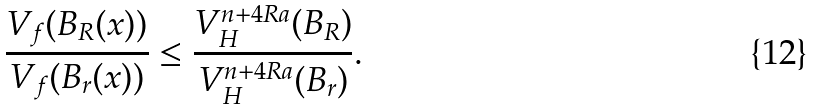<formula> <loc_0><loc_0><loc_500><loc_500>\frac { V _ { f } ( B _ { R } ( x ) ) } { V _ { f } ( B _ { r } ( x ) ) } & \leq \frac { V _ { H } ^ { n + 4 R a } ( B _ { R } ) } { V _ { H } ^ { n + 4 R a } ( B _ { r } ) } .</formula> 